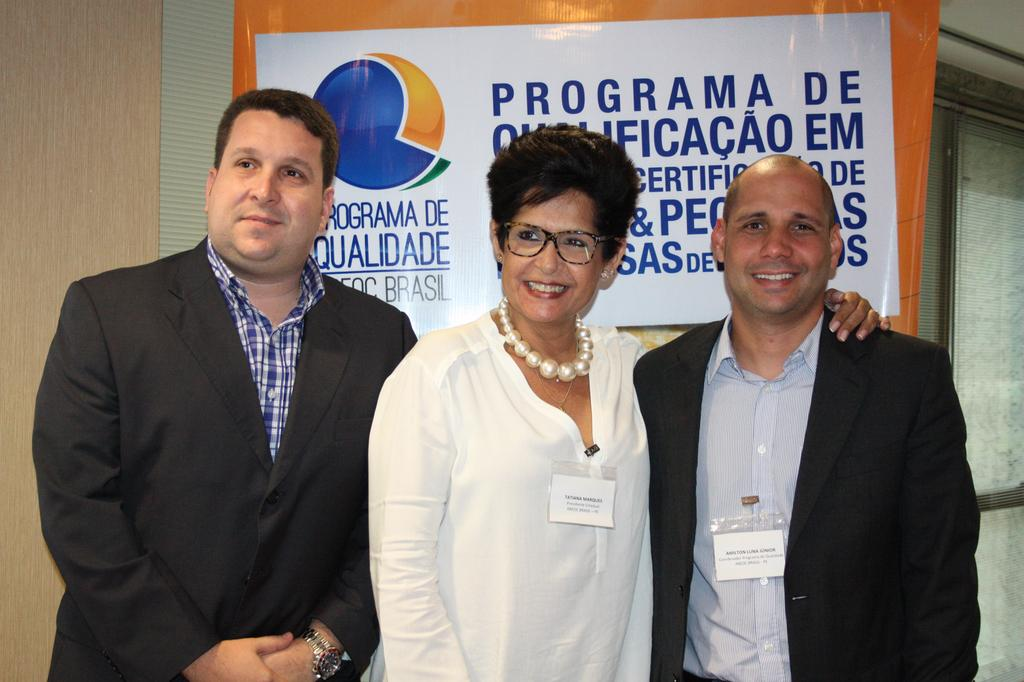How many people are present in the image? There are two men and a woman standing in the image. What can be seen in the background of the image? There is a wall in the background of the image. What is on the wall in the image? There is a banner on the wall. What is written on the banner? There is some text on the banner. How does the woman maintain her balance while standing on the window ledge in the image? There is no window ledge or indication of the woman standing on one in the image. 